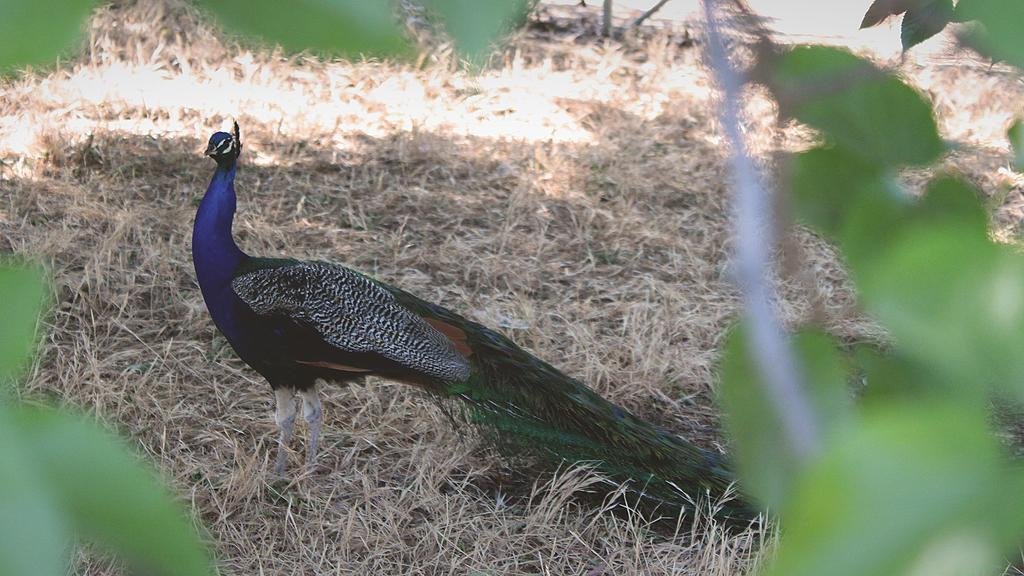What color is the grass in the image? The grass in the image is yellow-colored. What color are the leaves in the image? The leaves in the image are green-colored. What type of bird is present in the image? There is a peacock with blue and green colors in the image. How does the man feel about the disgusting father in the image? There is no man or father present in the image, so it is not possible to answer that question. 